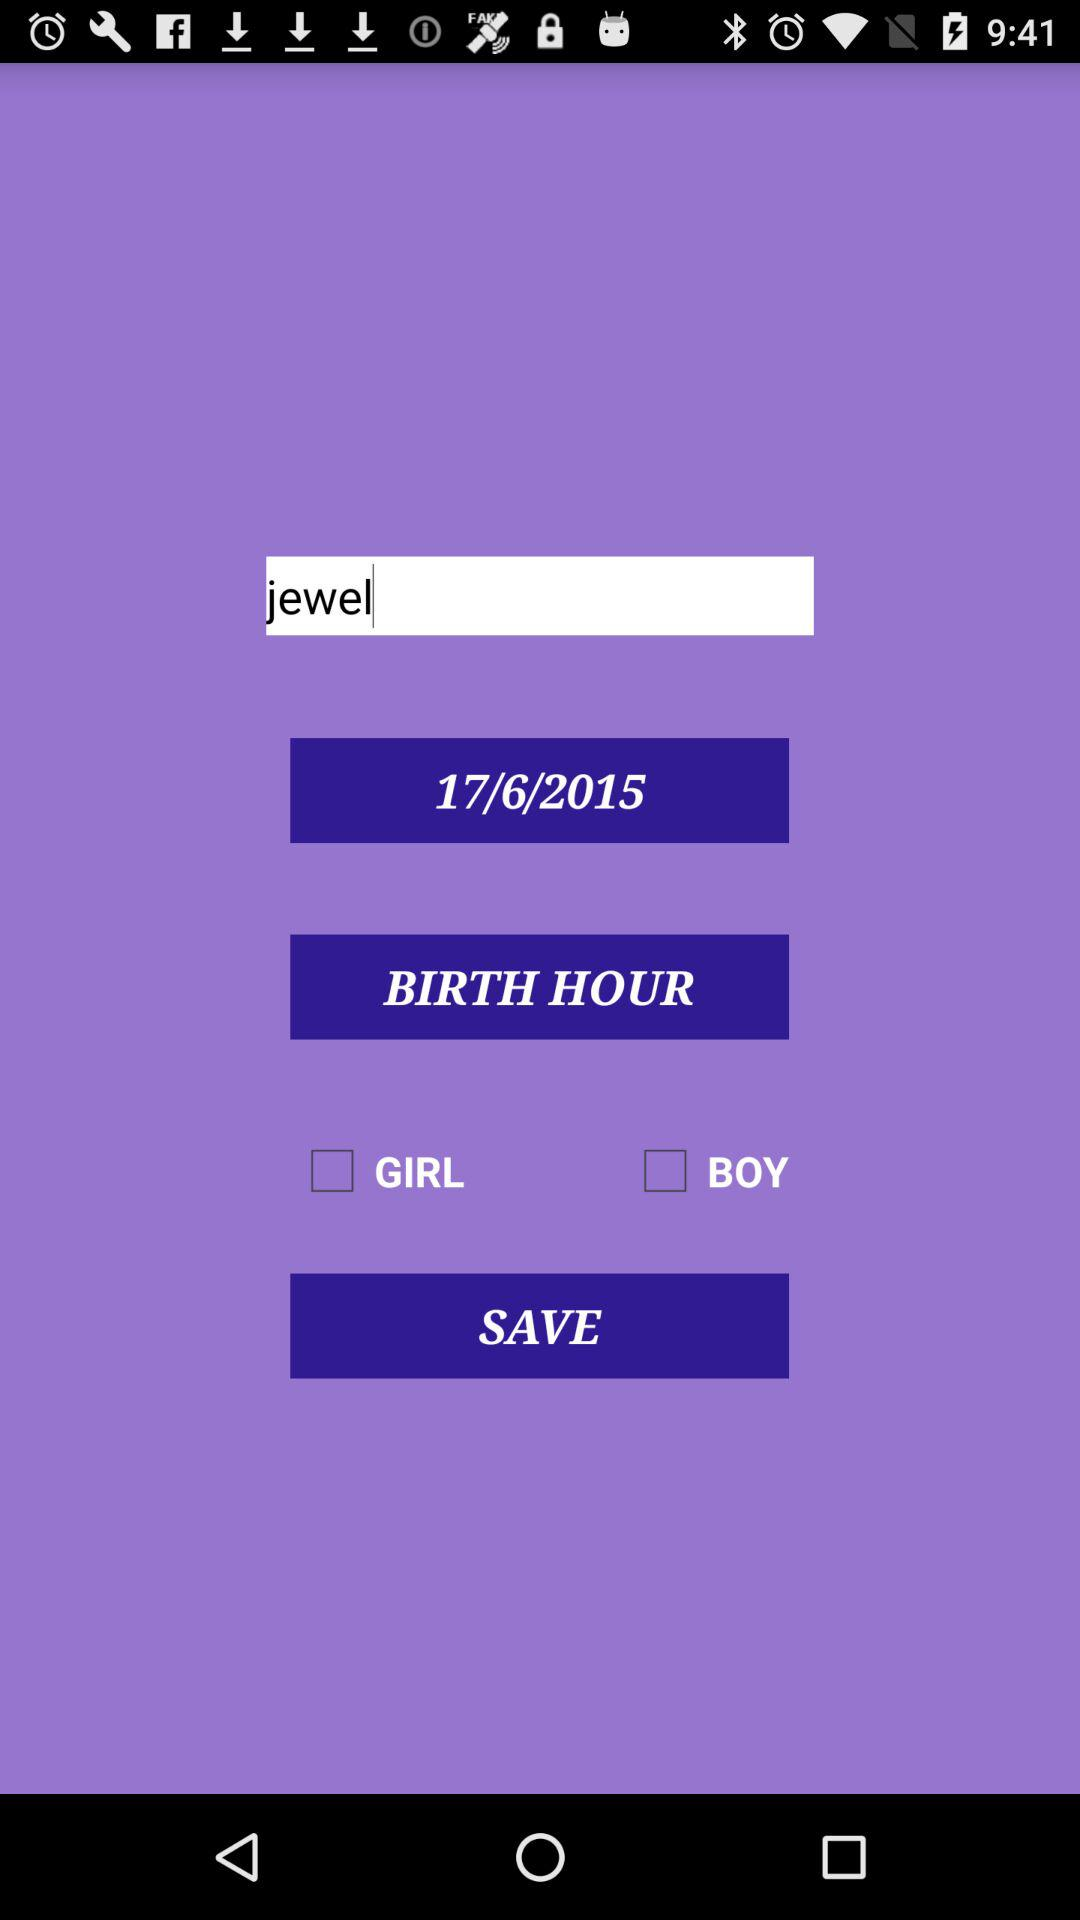What is the given date? The given date is June 17, 2015. 